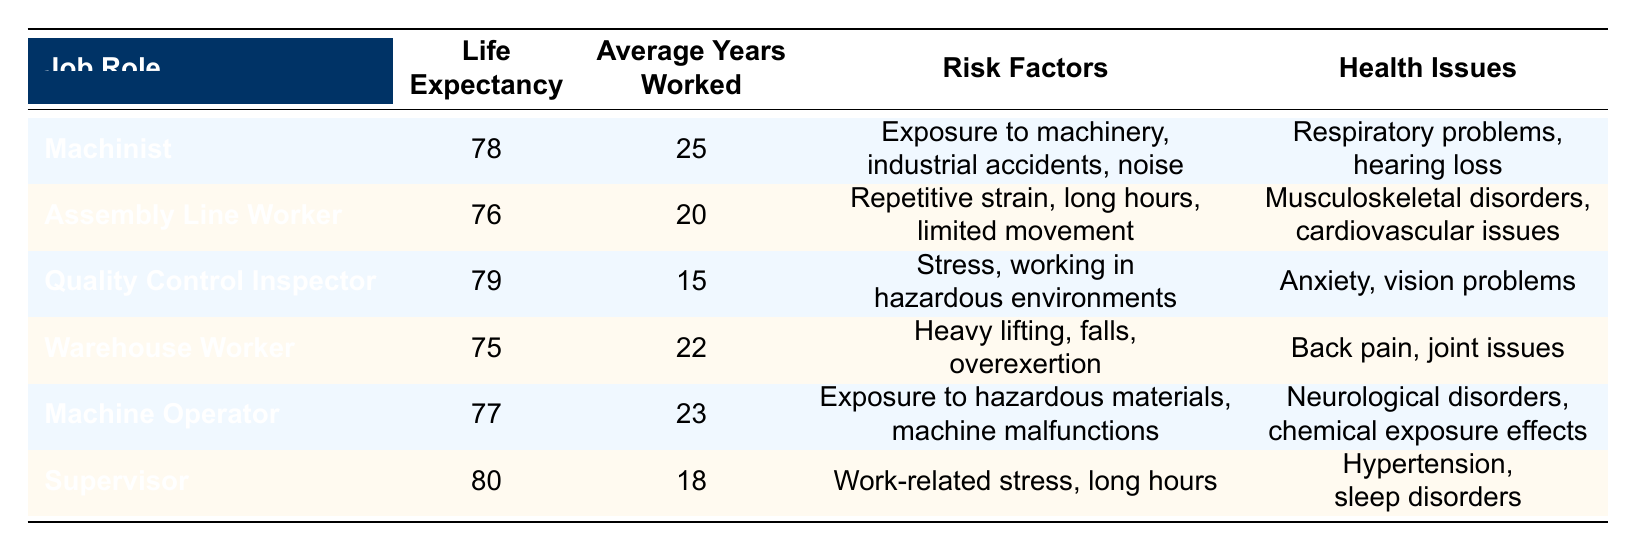What is the life expectancy of a Warehouse Worker? The life expectancy of a Warehouse Worker is listed in the table under the "Life Expectancy" column for that job role. According to the data, it shows 75 years.
Answer: 75 Which job role has the highest average years worked? By comparing the "Average Years Worked" column, we see that the Machinist has the highest average years worked, which is 25 years, while others are lower.
Answer: Machinist What are the health issues associated with Assembly Line Workers? By referring to the "Health Issues" column for the Assembly Line Worker, we can see that it lists musculoskeletal disorders and cardiovascular issues.
Answer: Musculoskeletal disorders, cardiovascular issues Is the life expectancy of a Supervisor higher than that of a Machinist? Comparing the life expectancies listed for both job roles, the Supervisor has a life expectancy of 80 years, while the Machinist has 78 years. Thus, the statement is true.
Answer: Yes What is the average life expectancy of all listed job roles? To find this, we add the life expectancies of all job roles: 78 + 76 + 79 + 75 + 77 + 80 = 465. There are 6 roles, so we calculate the average: 465 / 6 = 77.5.
Answer: 77.5 Do Quality Control Inspectors have lower life expectancy than Assembly Line Workers? The life expectancy for Quality Control Inspectors is 79 years, which is higher than the 76 years for Assembly Line Workers. Therefore, the statement is false.
Answer: No What common risk factor is shared by both Machinists and Machine Operators? By comparing the "Risk Factors" columns for both job roles, we see that exposure to hazardous materials is listed for Machine Operators, while Machinists have exposure to machinery. However, both roles involve risks linked to machinery, indicating a commonality.
Answer: Exposure to machinery What is the difference in life expectancy between the Supervisor and Warehouse Worker? The Supervisor has a life expectancy of 80 years, while the Warehouse Worker has 75 years. Therefore, the difference is calculated as 80 - 75 = 5 years.
Answer: 5 years Which job role has the least life expectancy? Referring to the "Life Expectancy" column, the Warehouse Worker has the least life expectancy at 75 years, compared to other roles.
Answer: Warehouse Worker 